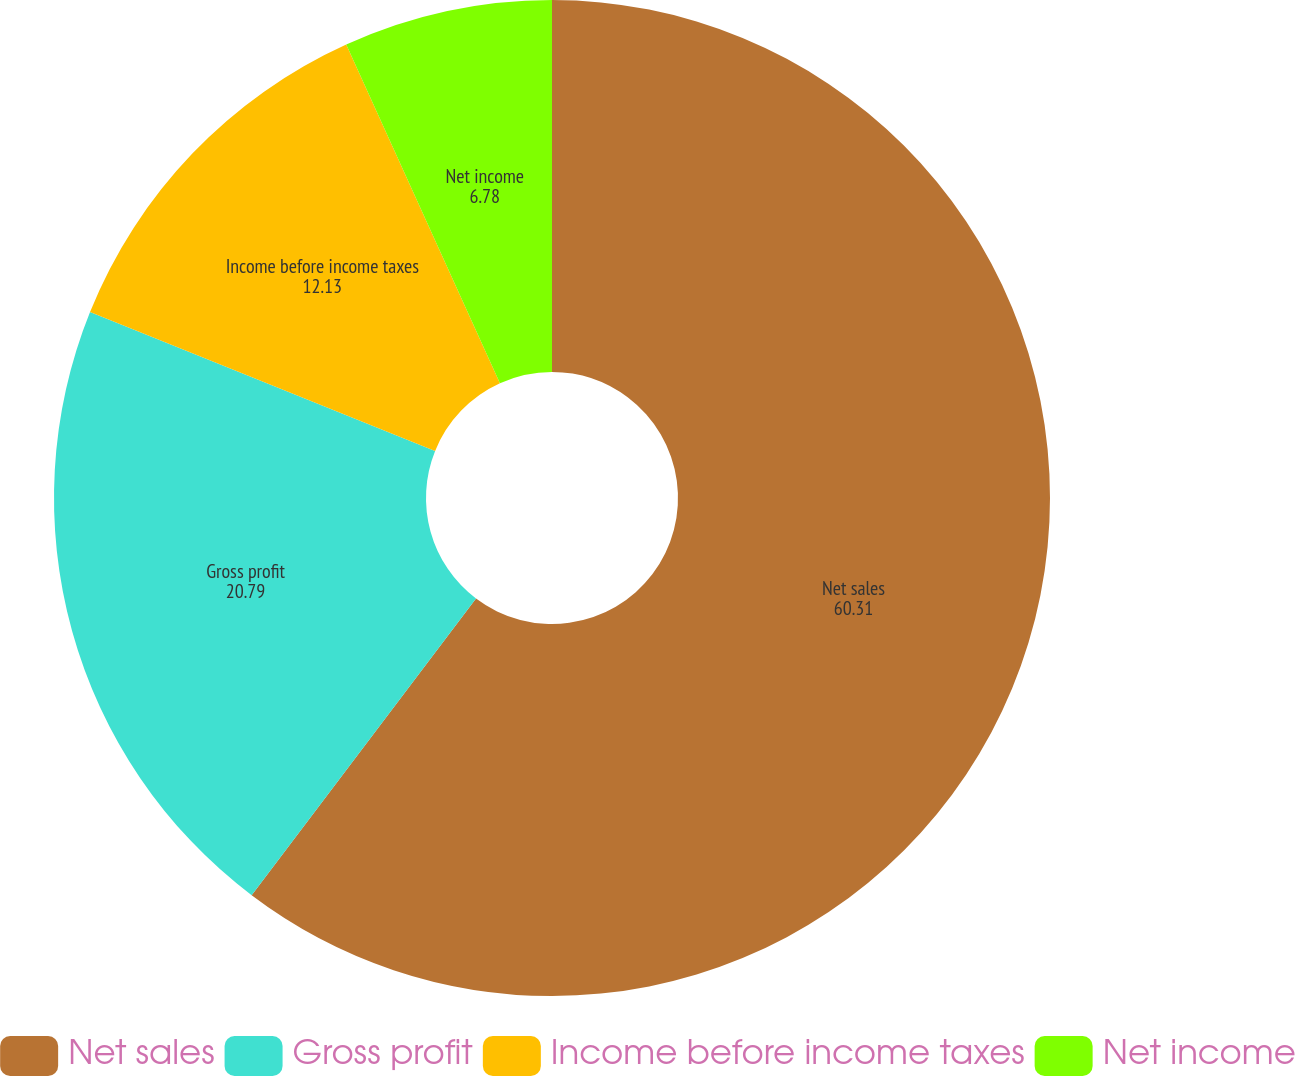Convert chart to OTSL. <chart><loc_0><loc_0><loc_500><loc_500><pie_chart><fcel>Net sales<fcel>Gross profit<fcel>Income before income taxes<fcel>Net income<nl><fcel>60.31%<fcel>20.79%<fcel>12.13%<fcel>6.78%<nl></chart> 